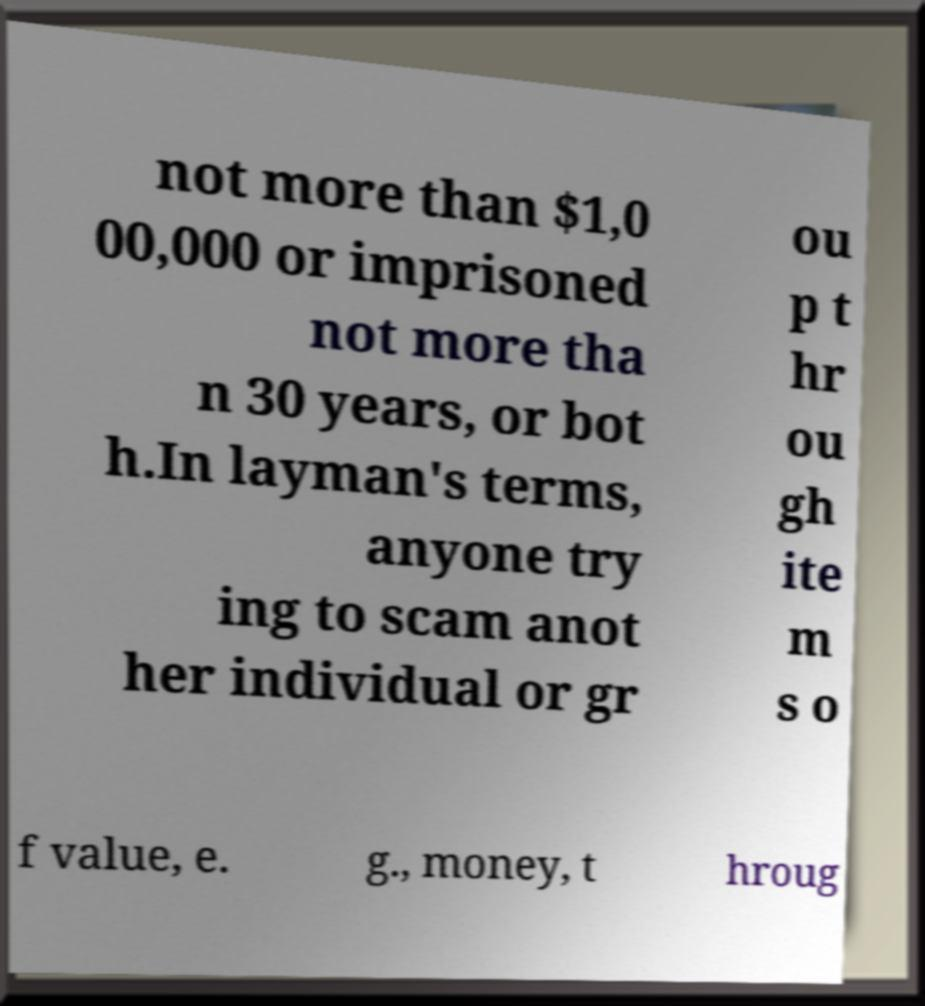Please read and relay the text visible in this image. What does it say? not more than $1,0 00,000 or imprisoned not more tha n 30 years, or bot h.In layman's terms, anyone try ing to scam anot her individual or gr ou p t hr ou gh ite m s o f value, e. g., money, t hroug 